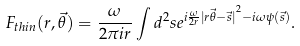<formula> <loc_0><loc_0><loc_500><loc_500>F _ { t h i n } ( r , { \vec { \theta } } ) = \frac { \omega } { 2 \pi i r } \int d ^ { 2 } s e ^ { i \frac { \omega } { 2 r } { | r \vec { \theta } - \vec { s } | } ^ { 2 } - i \omega \psi ( \vec { s } ) } .</formula> 